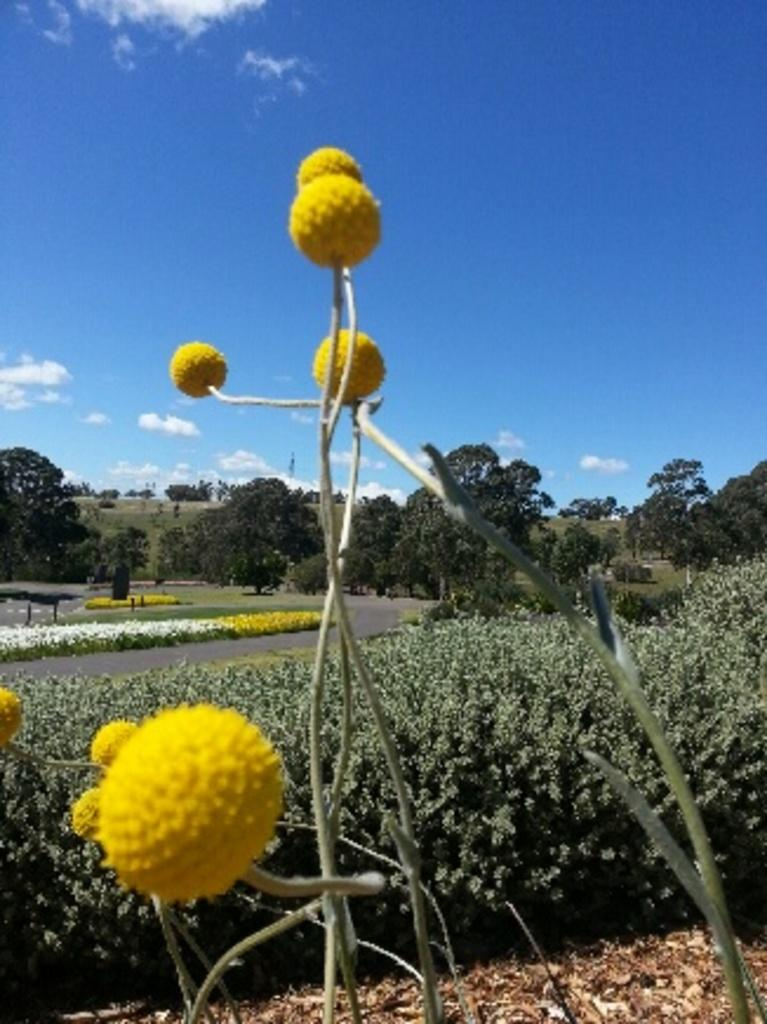What is the main feature of the image? There is a road in the image. What can be seen beside the road? There is grass beside the road. What other natural elements are present in the image? There are trees and flowers in the image. What is visible at the top of the image? The sky is visible at the top of the image. What type of cake is being served on the road in the image? There is no cake present in the image; it features a road with grass, trees, and flowers. Can you see a blade being used to cut the grass in the image? There is no blade visible in the image; the grass is simply present beside the road. 